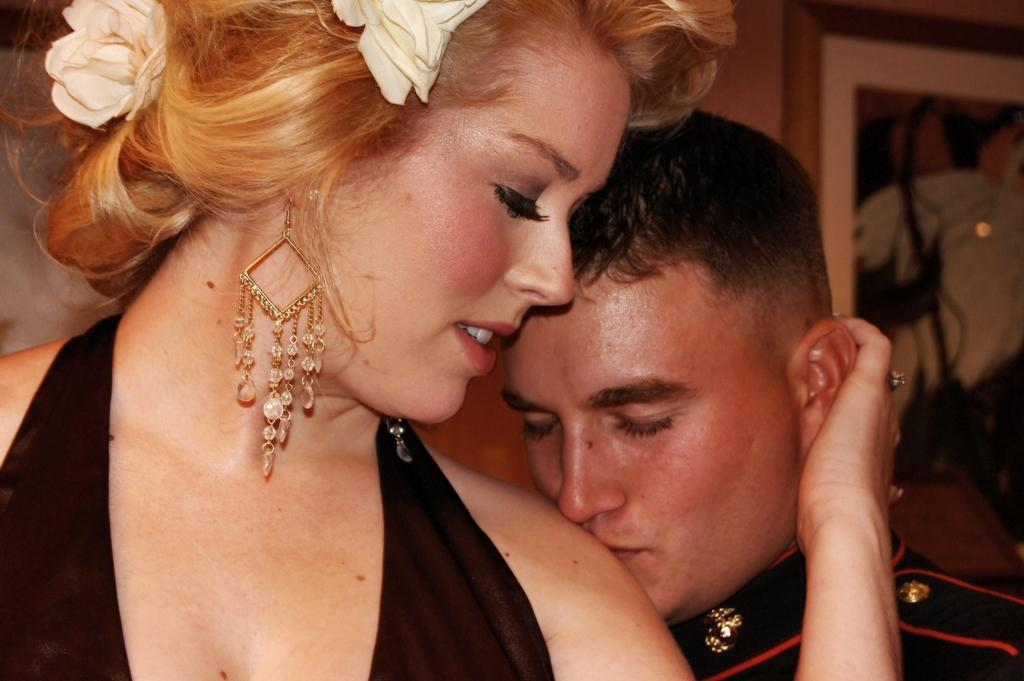Who are the people in the foreground of the image? There is a man and a woman in the foreground of the image. What can be seen on the wall in the background of the image? There is a photo frame on the wall in the background of the image. What type of skate is the man using to move around in the image? There is no skate present in the image, and the man's mode of movement is not specified. What tasks is the servant performing in the image? There is no mention of a servant in the image, so it is not possible to answer this question. 